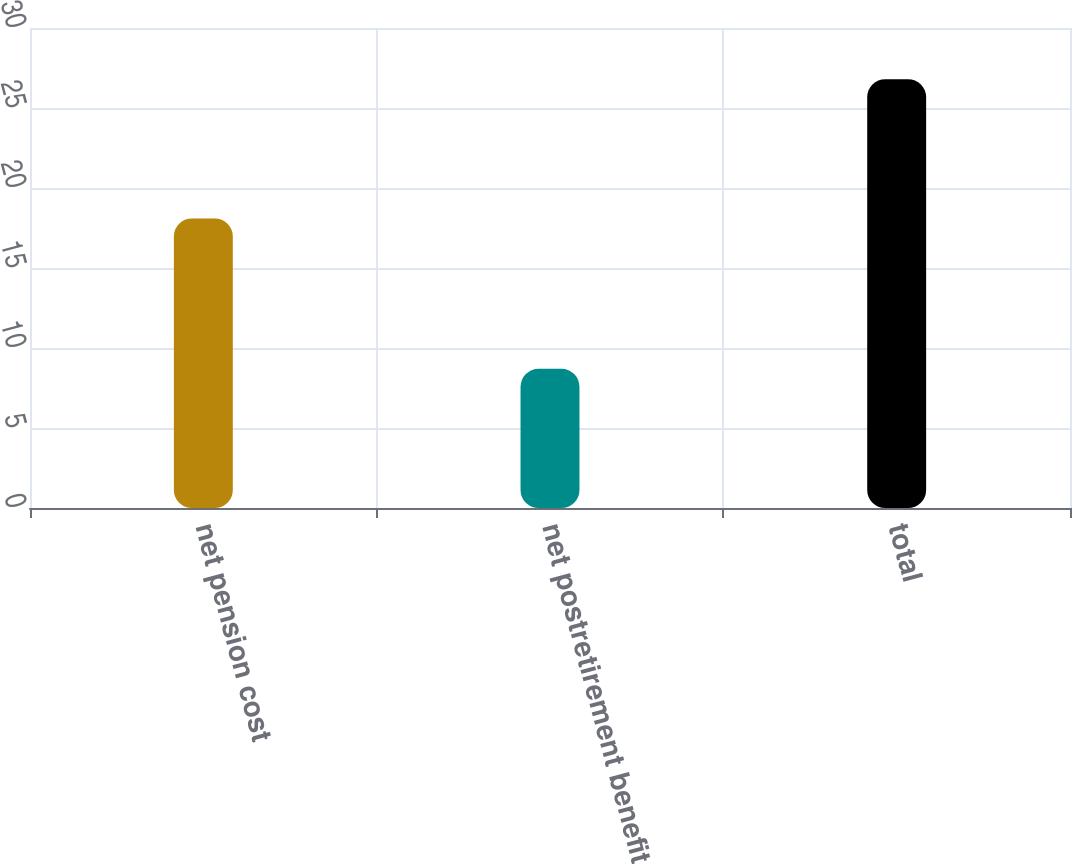<chart> <loc_0><loc_0><loc_500><loc_500><bar_chart><fcel>net pension cost<fcel>net postretirement benefit<fcel>total<nl><fcel>18.1<fcel>8.7<fcel>26.8<nl></chart> 